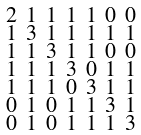<formula> <loc_0><loc_0><loc_500><loc_500>\begin{smallmatrix} 2 & 1 & 1 & 1 & 1 & 0 & 0 \\ 1 & 3 & 1 & 1 & 1 & 1 & 1 \\ 1 & 1 & 3 & 1 & 1 & 0 & 0 \\ 1 & 1 & 1 & 3 & 0 & 1 & 1 \\ 1 & 1 & 1 & 0 & 3 & 1 & 1 \\ 0 & 1 & 0 & 1 & 1 & 3 & 1 \\ 0 & 1 & 0 & 1 & 1 & 1 & 3 \end{smallmatrix}</formula> 